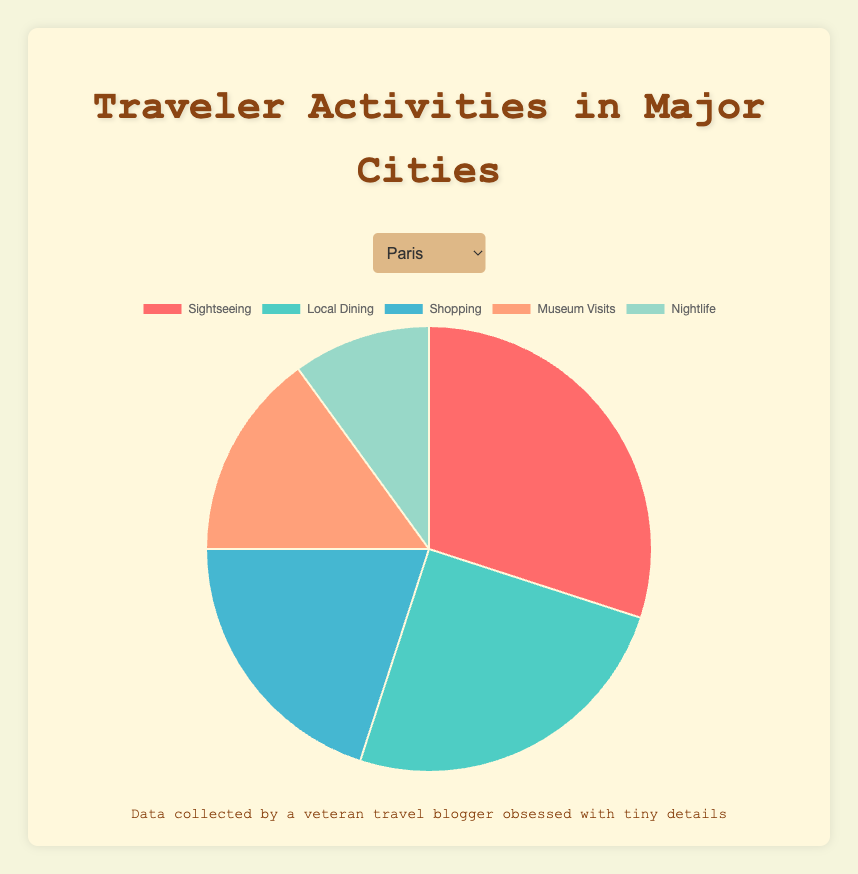What proportion of activities in Rome is spent on Sightseeing? Sightseeing in Rome is 40%. Look at the pie chart section labeled "Sightseeing".
Answer: 40% How does the proportion of Shopping in Tokyo compare to that in Paris? In Tokyo, Shopping accounts for 20%, whereas in Paris, it accounts for 20%. Compare the segments marked "Shopping" in both cities.
Answer: Equal Which city has the highest percentage of Sightseeing? Rome has the highest percentage of Sightseeing at 40%. Compare the "Sightseeing" segments across all cities.
Answer: Rome What is the total percentage of Local Dining and Nightlife in London? Local Dining in London is 23%, and Nightlife is 10%. Summing these, 23% + 10% = 33%.
Answer: 33% Is the proportion of Museum Visits in New York the same as in Barcelona? Both New York and Barcelona have a Museum Visits percentage of 15%.
Answer: Yes For Paris, what is the difference in proportion between Sightseeing and Nightlife? Sightseeing in Paris is 30%, and Nightlife is 10%. The difference is 30% - 10% = 20%.
Answer: 20% Which activity has the lowest percentage for all cities listed? Nightlife has the lowest percentage in all cities at 10%. Compare the "Nightlife" segments across all cities.
Answer: Nightlife Compare the proportions of Shopping activity in New York and London. Which city has a higher percentage? New York has a Shopping percentage of 25%, while London has 22%. New York has a higher percentage.
Answer: New York What is the average proportion of Museum Visits across all cities? Summing the Museum Visits percentages: 15% (Paris) + 15% (New York) + 15% (Tokyo) + 15% (Barcelona) + 12% (Rome) + 15% (London) = 87%. The average is 87% / 6 = 14.5%.
Answer: 14.5% What is the cumulative percentage of Shopping and Museum Visits in Paris? Shopping in Paris is 20%, and Museum Visits is 15%. The cumulative percentage is 20% + 15% = 35%.
Answer: 35% 